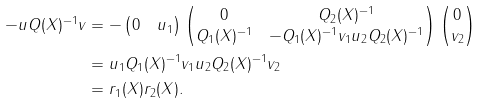Convert formula to latex. <formula><loc_0><loc_0><loc_500><loc_500>- u Q ( X ) ^ { - 1 } v & = - \begin{pmatrix} 0 & u _ { 1 } \end{pmatrix} \begin{pmatrix} 0 & Q _ { 2 } ( X ) ^ { - 1 } \\ Q _ { 1 } ( X ) ^ { - 1 } & - Q _ { 1 } ( X ) ^ { - 1 } v _ { 1 } u _ { 2 } Q _ { 2 } ( X ) ^ { - 1 } \end{pmatrix} \begin{pmatrix} 0 \\ v _ { 2 } \end{pmatrix} \\ & = u _ { 1 } Q _ { 1 } ( X ) ^ { - 1 } v _ { 1 } u _ { 2 } Q _ { 2 } ( X ) ^ { - 1 } v _ { 2 } \\ & = r _ { 1 } ( X ) r _ { 2 } ( X ) .</formula> 